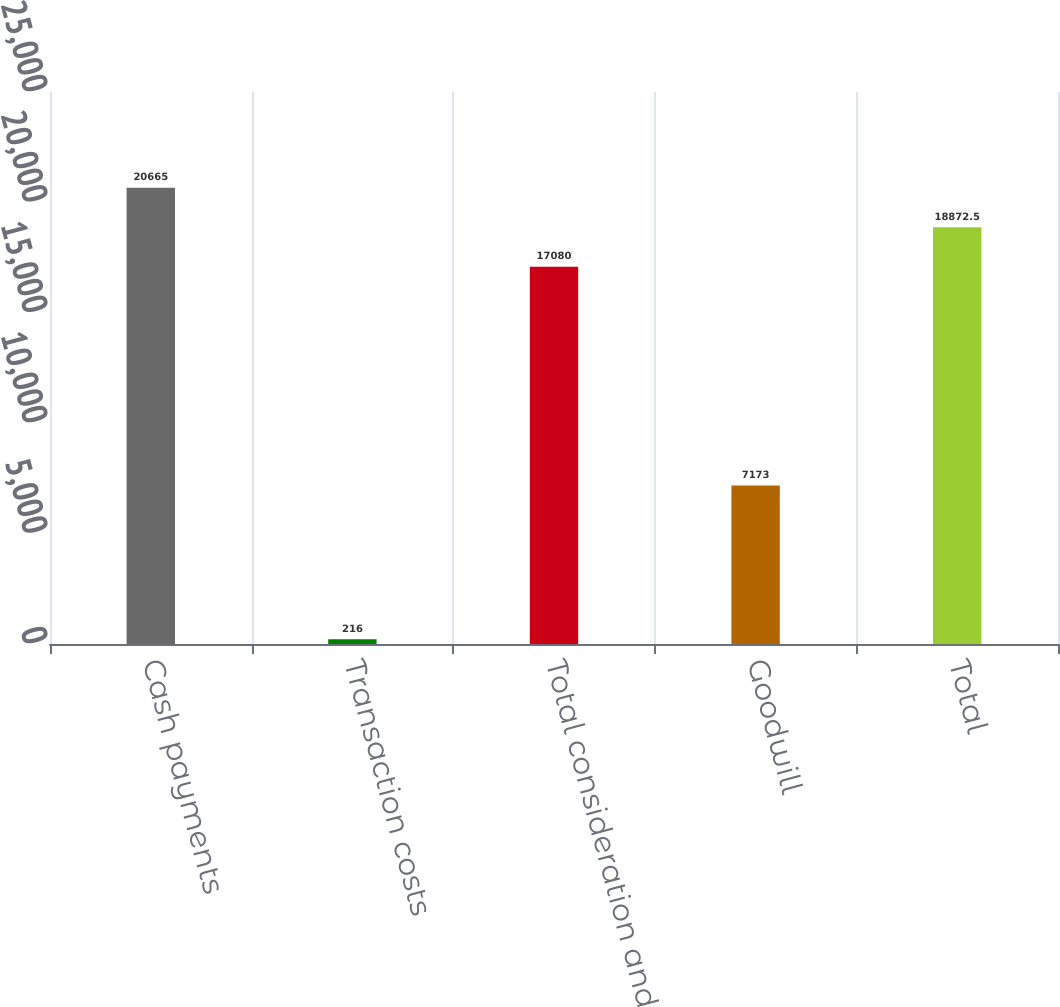Convert chart to OTSL. <chart><loc_0><loc_0><loc_500><loc_500><bar_chart><fcel>Cash payments<fcel>Transaction costs<fcel>Total consideration and<fcel>Goodwill<fcel>Total<nl><fcel>20665<fcel>216<fcel>17080<fcel>7173<fcel>18872.5<nl></chart> 